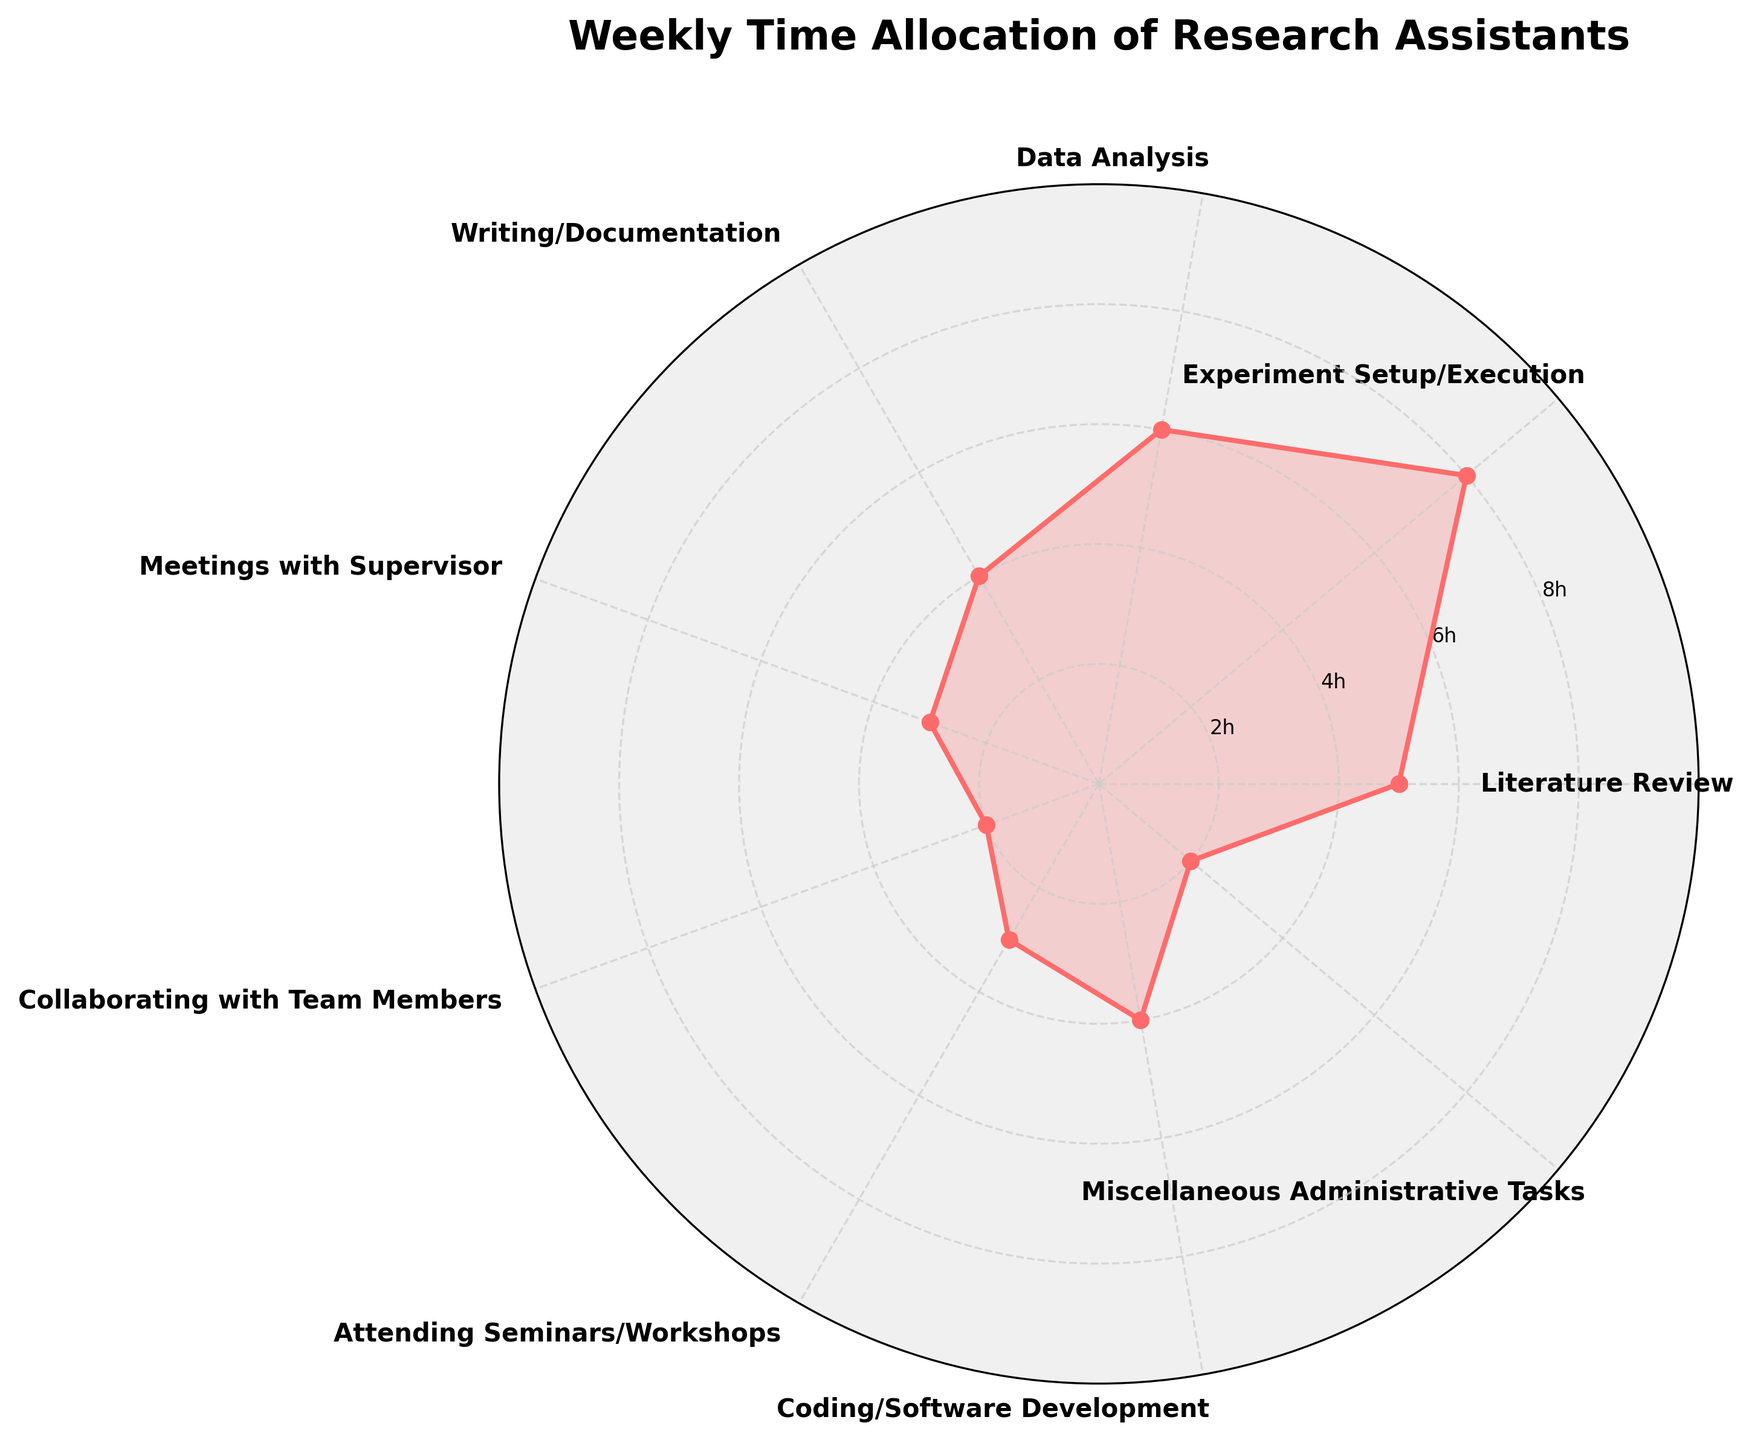What is the title of the chart? The title is located at the top of the chart. Here it specifies the purpose of the chart.
Answer: Weekly Time Allocation of Research Assistants What activity takes the most hours per week? The rose chart visually shows each activity's hours. The longest radius corresponds to Experiment Setup/Execution.
Answer: Experiment Setup/Execution How many activities are displayed in the chart? By counting the number of labeled spokes or segments in the rose chart, we can see each activity represented.
Answer: 9 Which activities take up the same amount of time per week? Look for activities that have segments or circles with the same radius length. Both Collaboration with Team Members and Miscellaneous Administrative Tasks have equal length segments.
Answer: Collaborating with Team Members, Miscellaneous Administrative Tasks How much more time is spent on Literature Review compared to Meetings with Supervisor? Subtract the hours for Meetings with Supervisor (3) from the hours for Literature Review (5). 5 - 3 = 2 hours more.
Answer: 2 hours What's the total time spent on Coding/Software Development and Writing/Documentation? Add the hours for Coding/Software Development (4) and Writing/Documentation (4). 4 + 4 = 8 hours.
Answer: 8 hours What’s the average weekly time spent on Literature Review, Data Analysis, and Meetings with Supervisor? Add the hours for Literature Review (5), Data Analysis (6), and Meetings with Supervisor (3) and divide by 3. (5 + 6 + 3) / 3 = 14 / 3 ≈ 4.67 hours.
Answer: 4.67 hours Which activity has the shortest time allocation? Identify the activity with the shortest radius. This is Collaborating with Team Members and Miscellaneous Administrative Tasks, both at 2 hours.
Answer: Collaborating with Team Members, Miscellaneous Administrative Tasks In terms of time spent, how does Attending Seminars/Workshops compare to Meetings with Supervisor? Compare the lengths of the segments. Attending Seminars/Workshops (3 hours) is equal to Meetings with Supervisor (3 hours).
Answer: Equal 